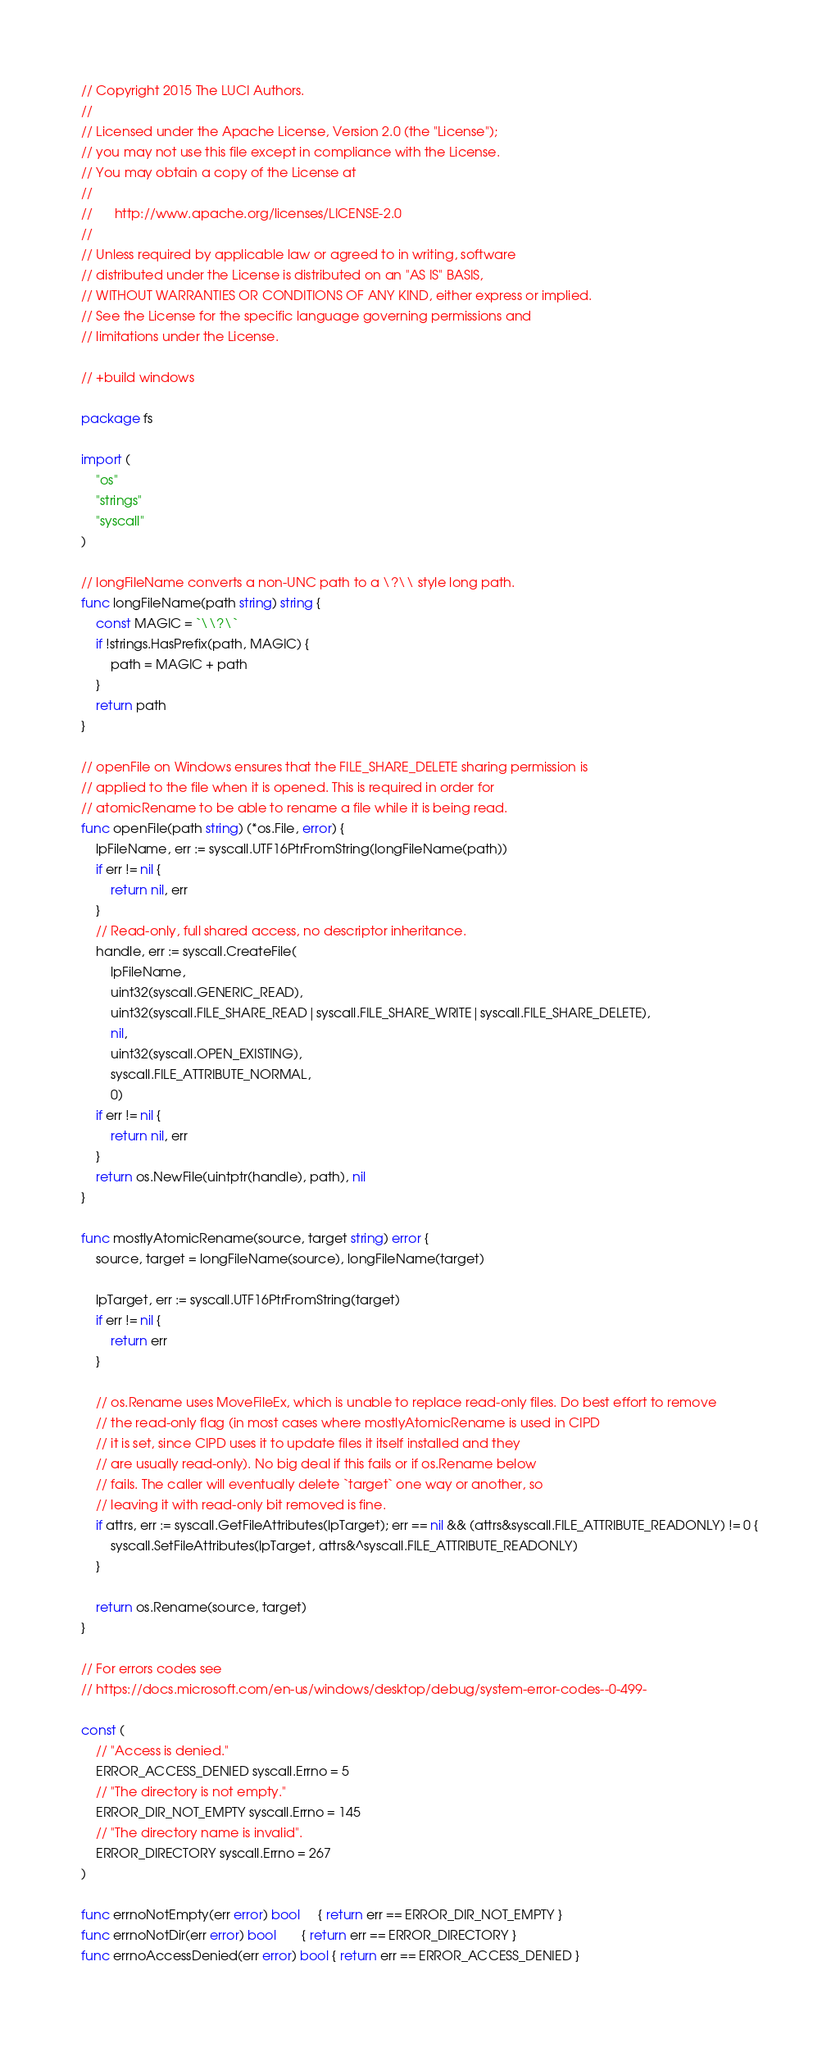<code> <loc_0><loc_0><loc_500><loc_500><_Go_>// Copyright 2015 The LUCI Authors.
//
// Licensed under the Apache License, Version 2.0 (the "License");
// you may not use this file except in compliance with the License.
// You may obtain a copy of the License at
//
//      http://www.apache.org/licenses/LICENSE-2.0
//
// Unless required by applicable law or agreed to in writing, software
// distributed under the License is distributed on an "AS IS" BASIS,
// WITHOUT WARRANTIES OR CONDITIONS OF ANY KIND, either express or implied.
// See the License for the specific language governing permissions and
// limitations under the License.

// +build windows

package fs

import (
	"os"
	"strings"
	"syscall"
)

// longFileName converts a non-UNC path to a \?\\ style long path.
func longFileName(path string) string {
	const MAGIC = `\\?\`
	if !strings.HasPrefix(path, MAGIC) {
		path = MAGIC + path
	}
	return path
}

// openFile on Windows ensures that the FILE_SHARE_DELETE sharing permission is
// applied to the file when it is opened. This is required in order for
// atomicRename to be able to rename a file while it is being read.
func openFile(path string) (*os.File, error) {
	lpFileName, err := syscall.UTF16PtrFromString(longFileName(path))
	if err != nil {
		return nil, err
	}
	// Read-only, full shared access, no descriptor inheritance.
	handle, err := syscall.CreateFile(
		lpFileName,
		uint32(syscall.GENERIC_READ),
		uint32(syscall.FILE_SHARE_READ|syscall.FILE_SHARE_WRITE|syscall.FILE_SHARE_DELETE),
		nil,
		uint32(syscall.OPEN_EXISTING),
		syscall.FILE_ATTRIBUTE_NORMAL,
		0)
	if err != nil {
		return nil, err
	}
	return os.NewFile(uintptr(handle), path), nil
}

func mostlyAtomicRename(source, target string) error {
	source, target = longFileName(source), longFileName(target)

	lpTarget, err := syscall.UTF16PtrFromString(target)
	if err != nil {
		return err
	}

	// os.Rename uses MoveFileEx, which is unable to replace read-only files. Do best effort to remove
	// the read-only flag (in most cases where mostlyAtomicRename is used in CIPD
	// it is set, since CIPD uses it to update files it itself installed and they
	// are usually read-only). No big deal if this fails or if os.Rename below
	// fails. The caller will eventually delete `target` one way or another, so
	// leaving it with read-only bit removed is fine.
	if attrs, err := syscall.GetFileAttributes(lpTarget); err == nil && (attrs&syscall.FILE_ATTRIBUTE_READONLY) != 0 {
		syscall.SetFileAttributes(lpTarget, attrs&^syscall.FILE_ATTRIBUTE_READONLY)
	}

	return os.Rename(source, target)
}

// For errors codes see
// https://docs.microsoft.com/en-us/windows/desktop/debug/system-error-codes--0-499-

const (
	// "Access is denied."
	ERROR_ACCESS_DENIED syscall.Errno = 5
	// "The directory is not empty."
	ERROR_DIR_NOT_EMPTY syscall.Errno = 145
	// "The directory name is invalid".
	ERROR_DIRECTORY syscall.Errno = 267
)

func errnoNotEmpty(err error) bool     { return err == ERROR_DIR_NOT_EMPTY }
func errnoNotDir(err error) bool       { return err == ERROR_DIRECTORY }
func errnoAccessDenied(err error) bool { return err == ERROR_ACCESS_DENIED }
</code> 